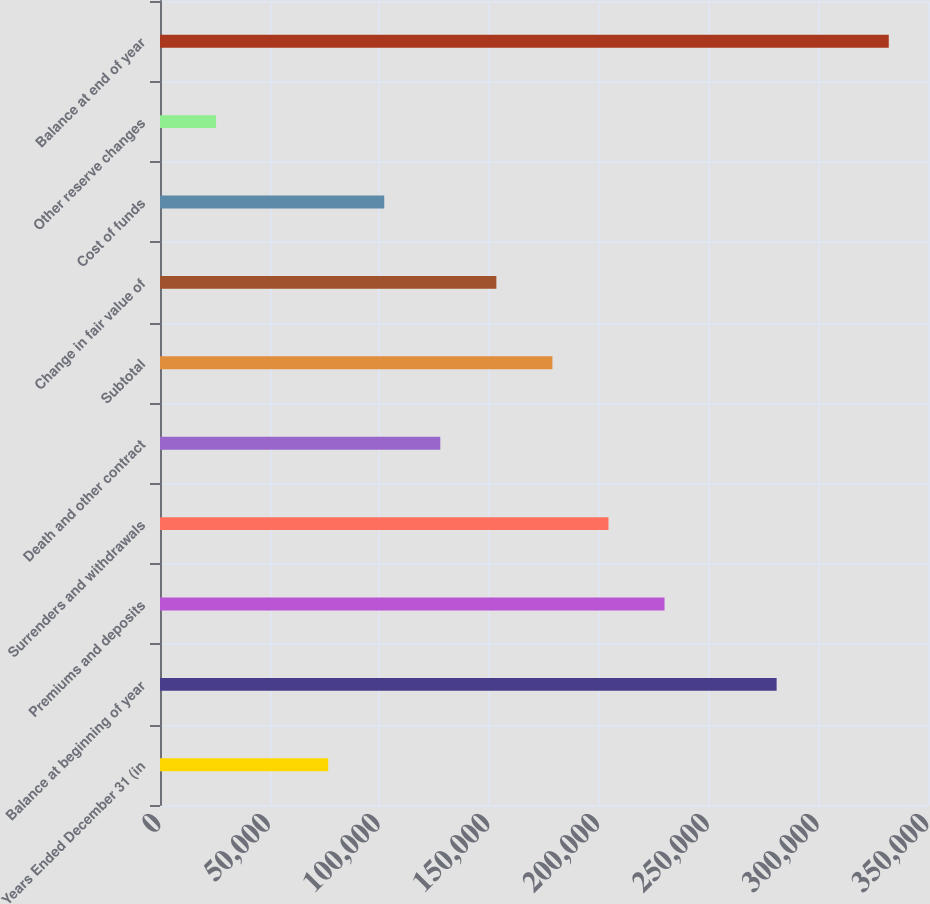Convert chart. <chart><loc_0><loc_0><loc_500><loc_500><bar_chart><fcel>Years Ended December 31 (in<fcel>Balance at beginning of year<fcel>Premiums and deposits<fcel>Surrenders and withdrawals<fcel>Death and other contract<fcel>Subtotal<fcel>Change in fair value of<fcel>Cost of funds<fcel>Other reserve changes<fcel>Balance at end of year<nl><fcel>76648.8<fcel>281022<fcel>229928<fcel>204382<fcel>127742<fcel>178835<fcel>153289<fcel>102195<fcel>25555.6<fcel>332115<nl></chart> 